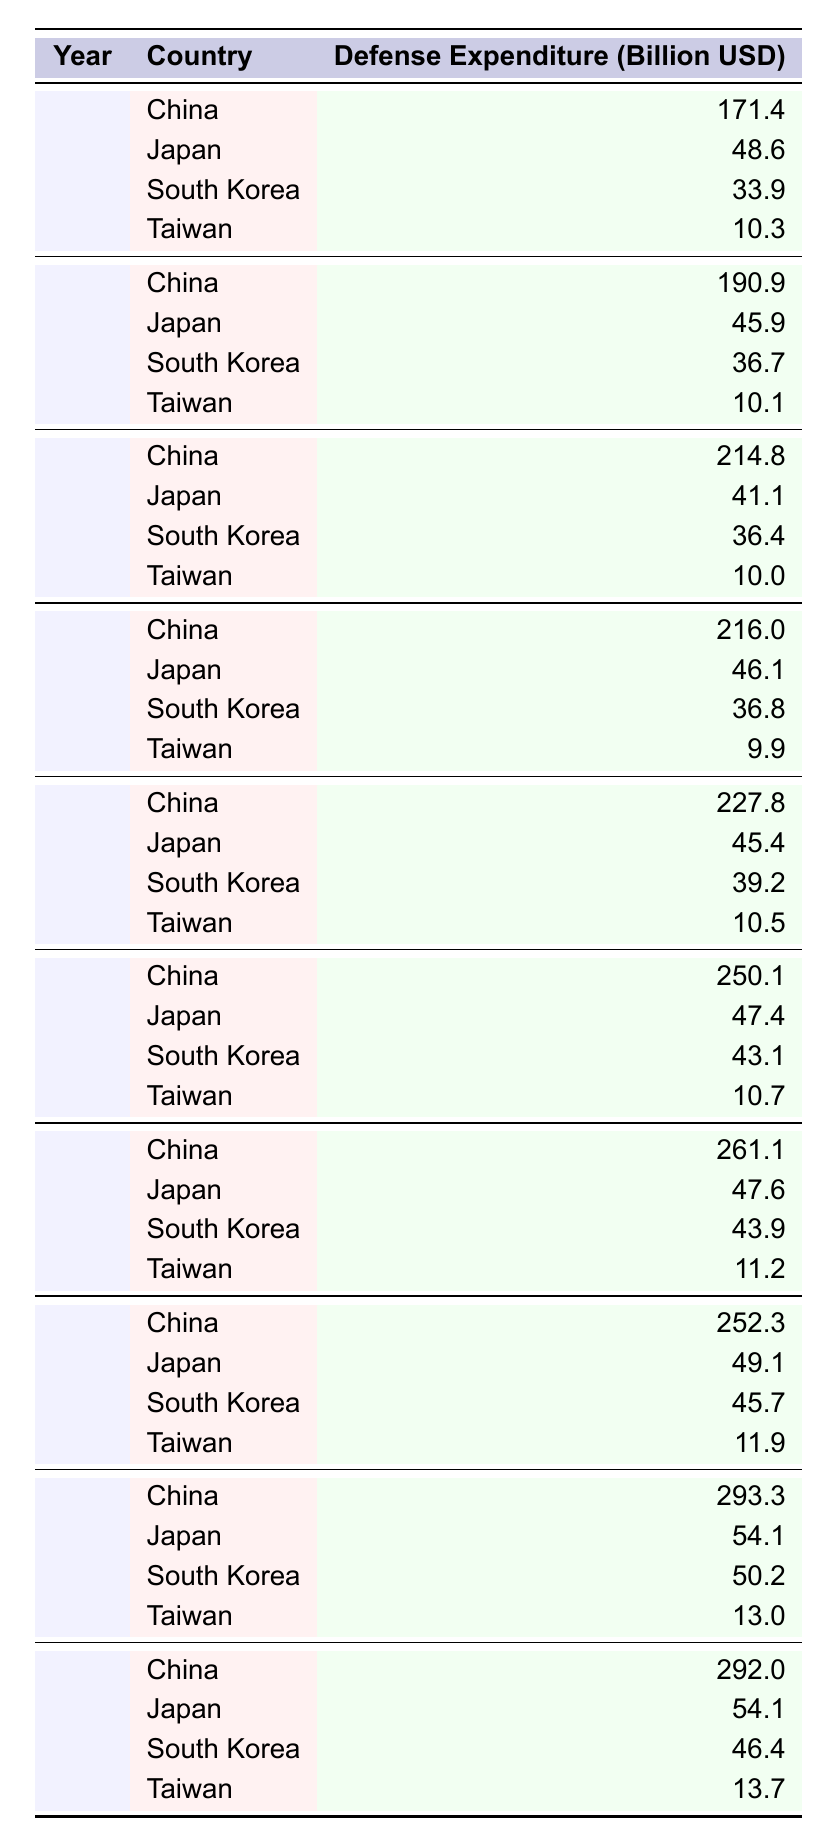What was the defense expenditure of China in 2021? From the table, we can locate the row for the year 2021 and find the corresponding value for China, which is 293.3 billion USD.
Answer: 293.3 billion USD Which country had the highest defense expenditure in 2019? Looking at the year 2019, China has the highest defense expenditure listed, which is 261.1 billion USD, compared to Japan at 47.6 billion USD, South Korea at 43.9 billion USD, and Taiwan at 11.2 billion USD.
Answer: China What is the difference in defense expenditure between Japan in 2013 and Japan in 2022? For Japan in 2013, the defense expenditure is 48.6 billion USD and in 2022 it is 54.1 billion USD. The difference is 54.1 - 48.6 = 5.5 billion USD.
Answer: 5.5 billion USD What was the average defense expenditure of Taiwan over the years in the table? The defense expenditures for Taiwan from 2013 to 2022 are 10.3, 10.1, 10.0, 9.9, 10.5, 10.7, 11.2, 11.9, 13.0, and 13.7 billion USD. Summing these gives  10.3 + 10.1 + 10.0 + 9.9 + 10.5 + 10.7 + 11.2 + 11.9 + 13.0 + 13.7 =  118.3 billion USD. Dividing by 10 years yields an average of 11.83 billion USD.
Answer: 11.83 billion USD Did South Korea's defense expenditure increase every year from 2013 to 2022? By examining the values for South Korea, the expenses are 33.9, 36.7, 36.4, 36.8, 39.2, 43.1, 43.9, 45.7, 50.2, and 46.4 billion USD. It shows an increase from 2013 to 2018, but then a decrease from 2021 to 2022 (50.2 to 46.4 billion USD). Therefore, it did not increase every year.
Answer: No What year saw the largest single-year increase in China's defense expenditure? By calculating the differences between successive years of China's expenditures: (190.9 - 171.4), (214.8 - 190.9), (216.0 - 214.8), (227.8 - 216.0), (250.1 - 227.8), (261.1 - 250.1), (252.3 - 261.1), (293.3 - 252.3), (292.0 - 293.3), we find that the largest increase was from 2020 to 2021, which shows a rise of 41 billion USD.
Answer: 2021 What was the total defense expenditure of all countries in 2018? The expenditures in 2018 were: China 250.1, Japan 47.4, South Korea 43.1, and Taiwan 10.7 billion USD. Summing these values gives 250.1 + 47.4 + 43.1 + 10.7 = 351.3 billion USD.
Answer: 351.3 billion USD Was there a year where Japan’s defense expenditure was equal to China’s expenditure? By scanning the table, it is clear that there are no years where Japan's defense expenditure matches China's. The values are significantly lower, with the maximum for Japan being 54.1 billion USD and for China 293.3 billion USD in 2021.
Answer: No 